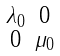<formula> <loc_0><loc_0><loc_500><loc_500>\begin{smallmatrix} \lambda _ { 0 } & 0 \\ 0 & \mu _ { 0 } \end{smallmatrix}</formula> 